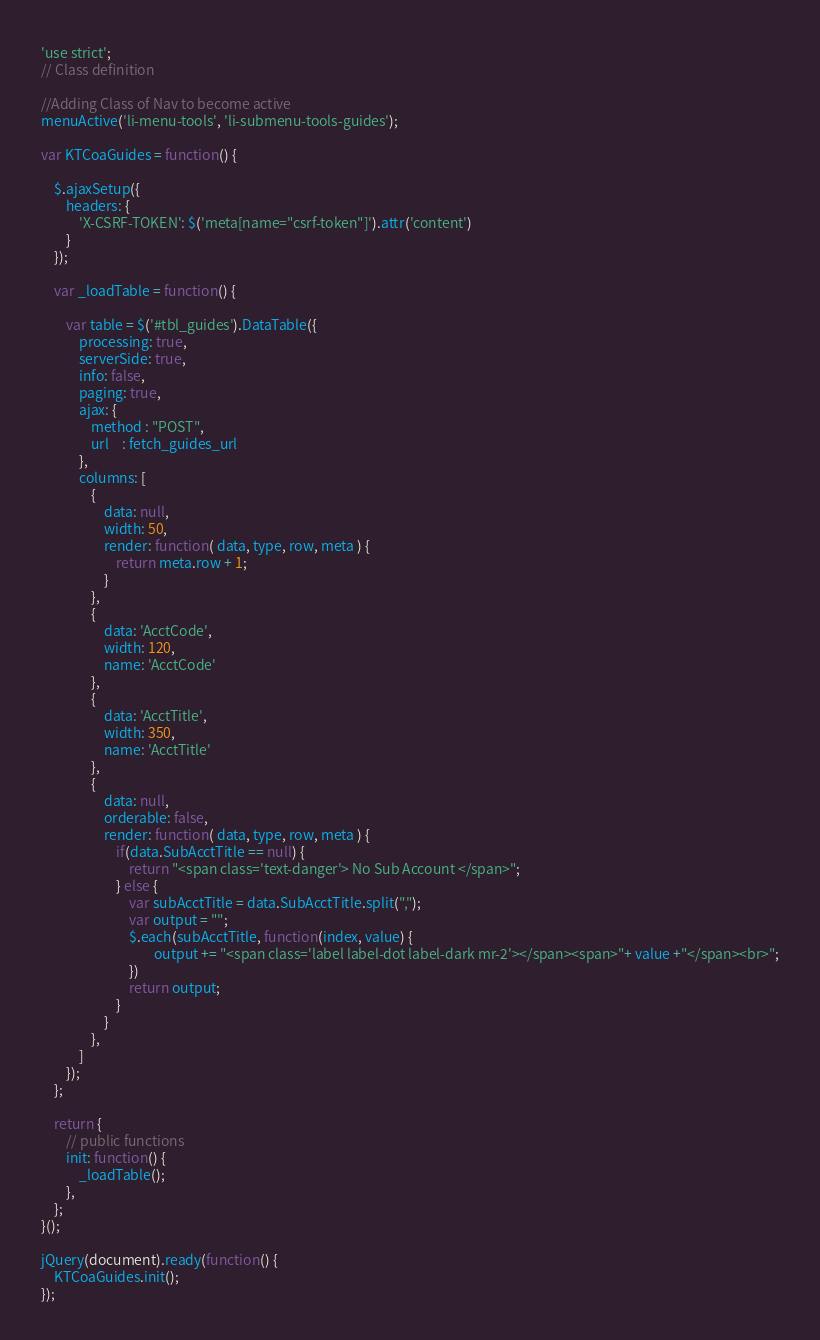<code> <loc_0><loc_0><loc_500><loc_500><_JavaScript_>'use strict';
// Class definition

//Adding Class of Nav to become active
menuActive('li-menu-tools', 'li-submenu-tools-guides');

var KTCoaGuides = function() {

    $.ajaxSetup({
        headers: {
            'X-CSRF-TOKEN': $('meta[name="csrf-token"]').attr('content')
        }
    });

    var _loadTable = function() {

        var table = $('#tbl_guides').DataTable({
            processing: true,
            serverSide: true,
            info: false,
            paging: true,
            ajax: {
                method : "POST",
                url    : fetch_guides_url
            },
            columns: [
                {
                    data: null,
                    width: 50,
                    render: function( data, type, row, meta ) {
                        return meta.row + 1;
                    }
                },
                {
                    data: 'AcctCode',
                    width: 120,
                    name: 'AcctCode'
                },
                {
                    data: 'AcctTitle',
                    width: 350,
                    name: 'AcctTitle'
                },
                {   
                    data: null,
                    orderable: false,
                    render: function( data, type, row, meta ) {
                        if(data.SubAcctTitle == null) {
                            return "<span class='text-danger'> No Sub Account </span>";
                        } else {
                            var subAcctTitle = data.SubAcctTitle.split(",");
                            var output = "";
                            $.each(subAcctTitle, function(index, value) {
                                    output += "<span class='label label-dot label-dark mr-2'></span><span>"+ value +"</span><br>";
                            })
                            return output;
                        }
                    }
                },
            ]
        });
    };

    return {
        // public functions
        init: function() {
            _loadTable();
        },
    };
}();

jQuery(document).ready(function() {
    KTCoaGuides.init();
});
</code> 